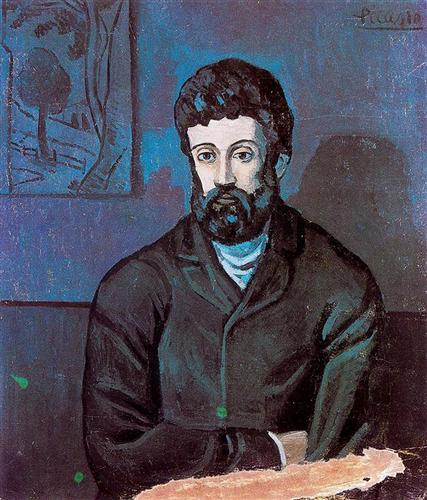How does the choice of colors influence the mood of the painting? The dominant use of blue in the portrait sets a deeply introspective and calm ambiance. Blue often conveys serenity and depth, which resonates with the subject’s contemplative expression. The contrasts provided by the dark jacket and the bright hints of green in the tree sketch inject a subtle dynamism into the composition, suggesting layers of emotion beneath the surface calm. Overall, the color palette skillfully underscores the introspective and complex mood of the piece. 